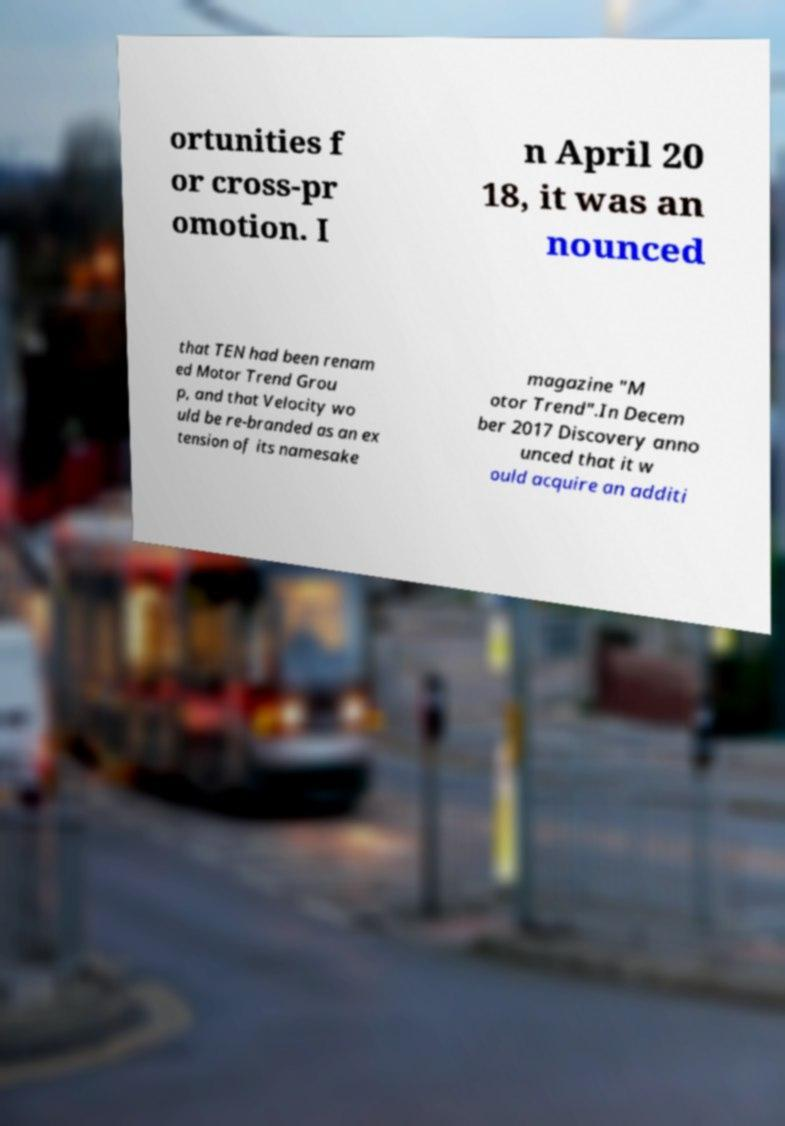Please identify and transcribe the text found in this image. ortunities f or cross-pr omotion. I n April 20 18, it was an nounced that TEN had been renam ed Motor Trend Grou p, and that Velocity wo uld be re-branded as an ex tension of its namesake magazine "M otor Trend".In Decem ber 2017 Discovery anno unced that it w ould acquire an additi 